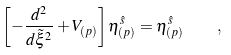<formula> <loc_0><loc_0><loc_500><loc_500>\left [ - { \frac { d ^ { 2 } } { d \tilde { \xi } ^ { 2 } } } + V _ { ( p ) } \right ] \eta _ { ( p ) } ^ { \hat { s } } = \eta _ { ( p ) } ^ { \hat { s } } \quad ,</formula> 